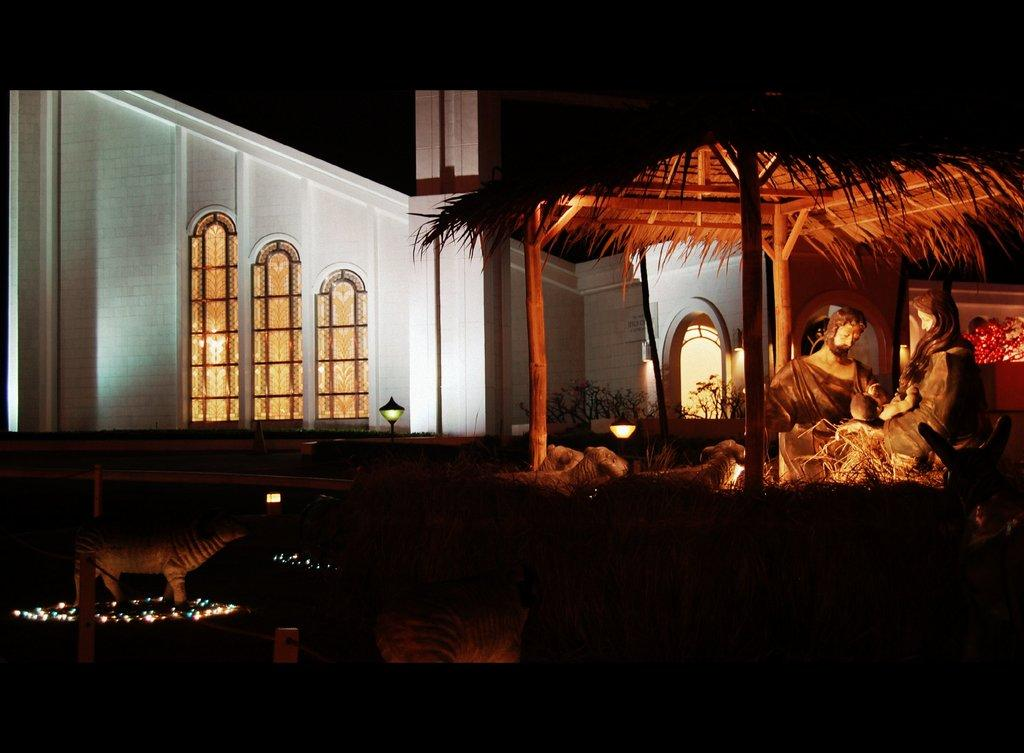What type of art is featured in the image? There are sculptures in the image. What type of structure is located in front of the building? There is a hut in the image. What is the background of the image? There is a building behind the hut. What can be seen illuminating the scene? Lights are present in the image. What type of dress is the army wearing in the image? There is no army or dress present in the image; it features sculptures, a hut, a building, and lights. How many cats can be seen playing with the sculptures in the image? There are no cats present in the image; it features sculptures, a hut, a building, and lights. 